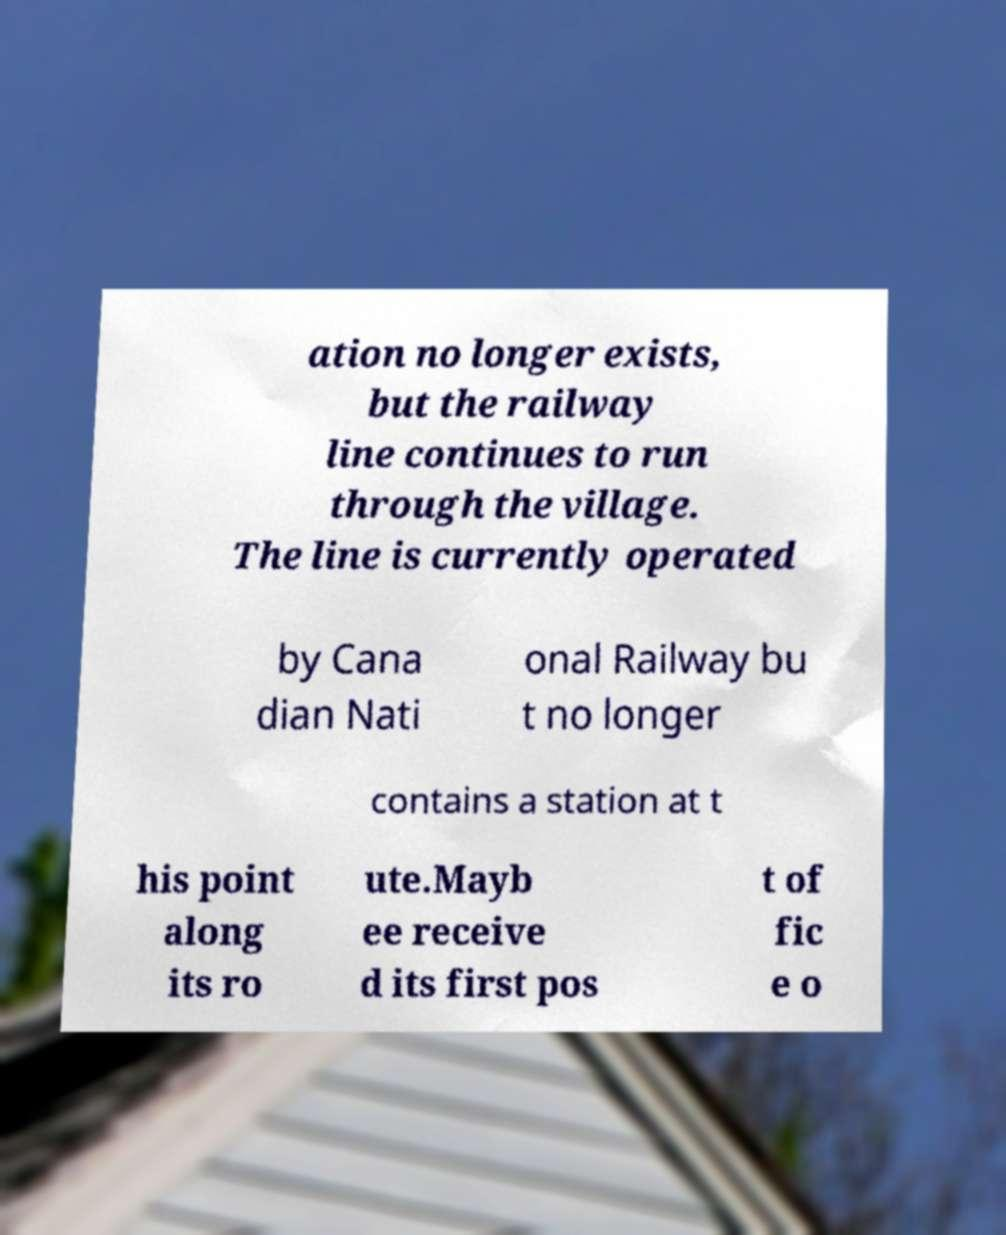There's text embedded in this image that I need extracted. Can you transcribe it verbatim? ation no longer exists, but the railway line continues to run through the village. The line is currently operated by Cana dian Nati onal Railway bu t no longer contains a station at t his point along its ro ute.Mayb ee receive d its first pos t of fic e o 